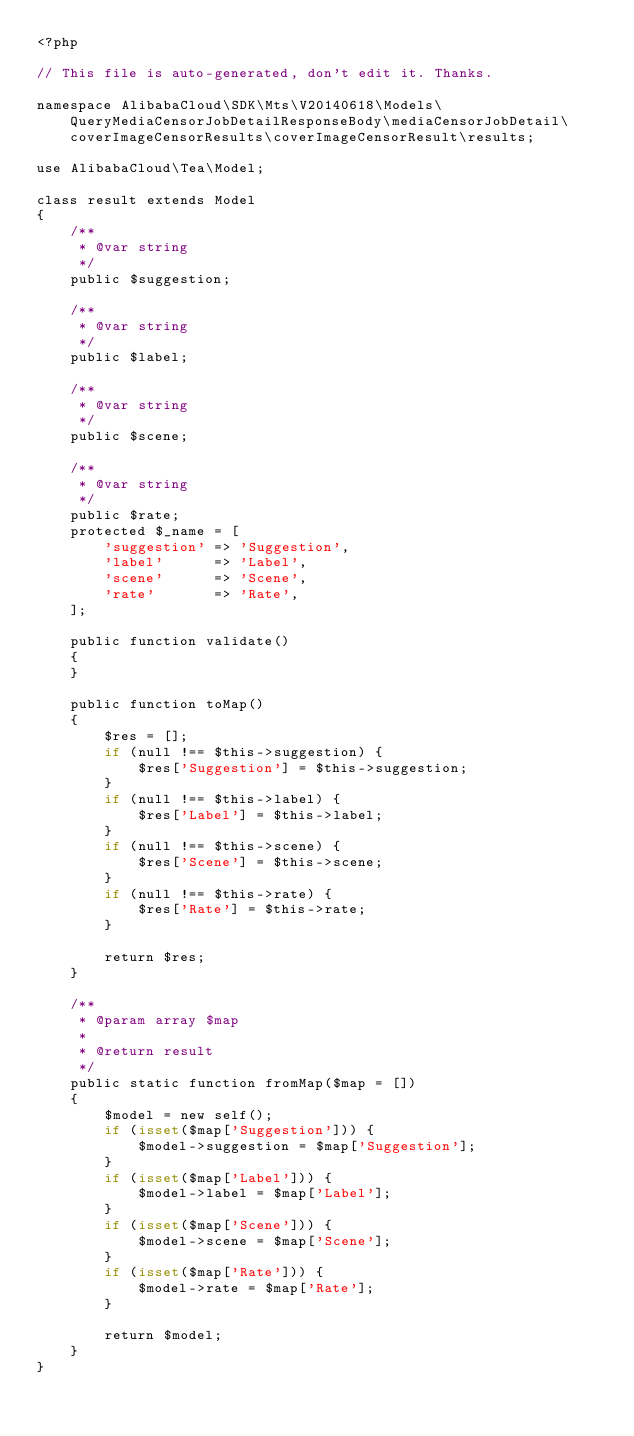<code> <loc_0><loc_0><loc_500><loc_500><_PHP_><?php

// This file is auto-generated, don't edit it. Thanks.

namespace AlibabaCloud\SDK\Mts\V20140618\Models\QueryMediaCensorJobDetailResponseBody\mediaCensorJobDetail\coverImageCensorResults\coverImageCensorResult\results;

use AlibabaCloud\Tea\Model;

class result extends Model
{
    /**
     * @var string
     */
    public $suggestion;

    /**
     * @var string
     */
    public $label;

    /**
     * @var string
     */
    public $scene;

    /**
     * @var string
     */
    public $rate;
    protected $_name = [
        'suggestion' => 'Suggestion',
        'label'      => 'Label',
        'scene'      => 'Scene',
        'rate'       => 'Rate',
    ];

    public function validate()
    {
    }

    public function toMap()
    {
        $res = [];
        if (null !== $this->suggestion) {
            $res['Suggestion'] = $this->suggestion;
        }
        if (null !== $this->label) {
            $res['Label'] = $this->label;
        }
        if (null !== $this->scene) {
            $res['Scene'] = $this->scene;
        }
        if (null !== $this->rate) {
            $res['Rate'] = $this->rate;
        }

        return $res;
    }

    /**
     * @param array $map
     *
     * @return result
     */
    public static function fromMap($map = [])
    {
        $model = new self();
        if (isset($map['Suggestion'])) {
            $model->suggestion = $map['Suggestion'];
        }
        if (isset($map['Label'])) {
            $model->label = $map['Label'];
        }
        if (isset($map['Scene'])) {
            $model->scene = $map['Scene'];
        }
        if (isset($map['Rate'])) {
            $model->rate = $map['Rate'];
        }

        return $model;
    }
}
</code> 